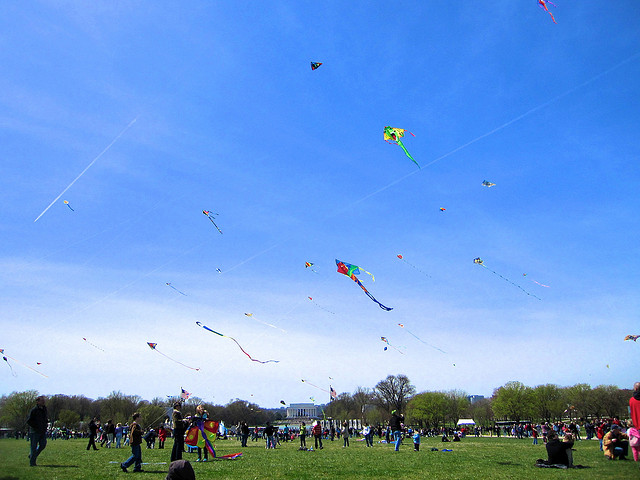<image>How many lightbulbs are needed if two are out? It's uncertain. You might need none, one, or two lightbulbs. How many lightbulbs are needed if two are out? It depends on the situation. If two lightbulbs are out, it is possible that only one lightbulb is needed. However, it can vary depending on the specific circumstances. 